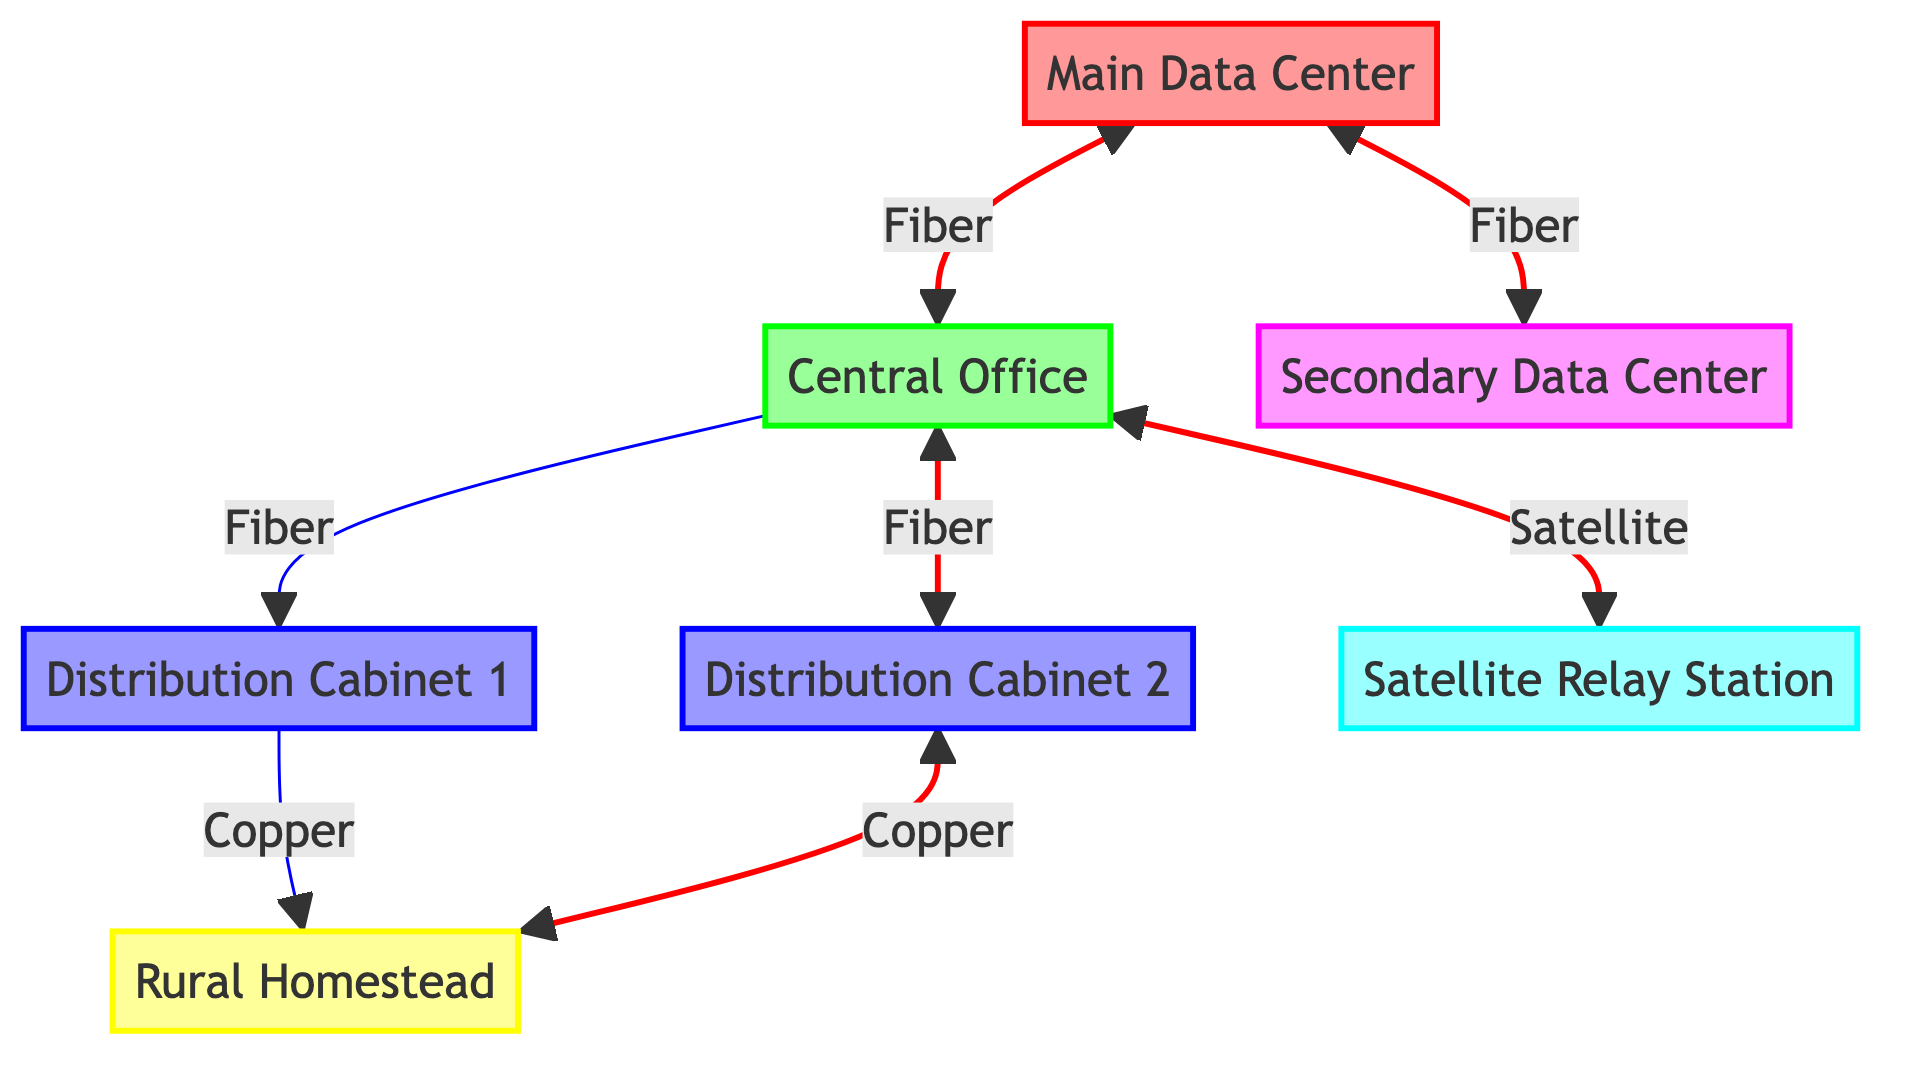What is the main function of the "Main Data Center"? The "Main Data Center" serves as the primary data center located in the town's center with high-capacity, high-reliability server racks.
Answer: Primary data center How many distribution points are there in the network? The diagram has two distribution points: "Distribution Cabinet 1" and "Distribution Cabinet 2".
Answer: 2 Which node provides a connection to the "Satellite Relay Station"? The "Central Office" provides the connection to the "Satellite Relay Station" through a satellite link.
Answer: Central Office What type of connection links the "Main Data Center" to the "Secondary Data Center"? The connection type linking the "Main Data Center" to the "Secondary Data Center" is a fiber connection.
Answer: Fiber connection Is there a redundant connection from "Central Office" to "Distribution Cabinet 1"? No, the connection from "Central Office" to "Distribution Cabinet 1" is not redundant, indicating it's a standard connection.
Answer: No What is the role of the "Distribution Cabinet 2"? "Distribution Cabinet 2" is located in the southern region and provides redundancy and load balancing for customer connections.
Answer: Redundancy and load balancing How many total connections are shown in the diagram? The diagram illustrates seven connections linking various nodes together.
Answer: 7 Which connection type is used for rural homestead connections? The connections to the rural homesteads use a copper connection type for individual customer connectivity.
Answer: Copper connection Which nodes have redundant pathways? The nodes with redundant pathways include the "Main Data Center", "Central Office", "Distribution Cabinet 2", and the "Rural Homestead".
Answer: Main Data Center, Central Office, Distribution Cabinet 2, Rural Homestead 